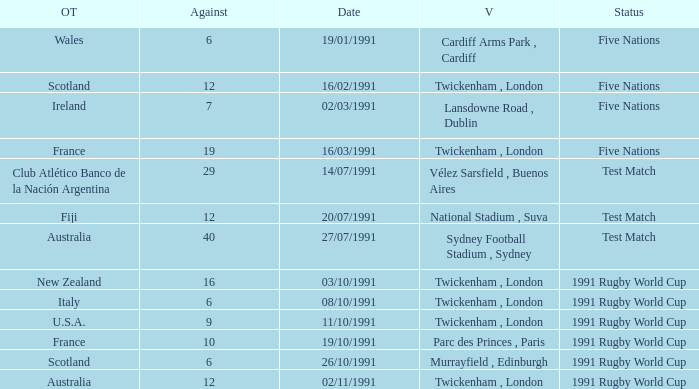What is Date, when Opposing Teams is "Australia", and when Venue is "Twickenham , London"? 02/11/1991. 